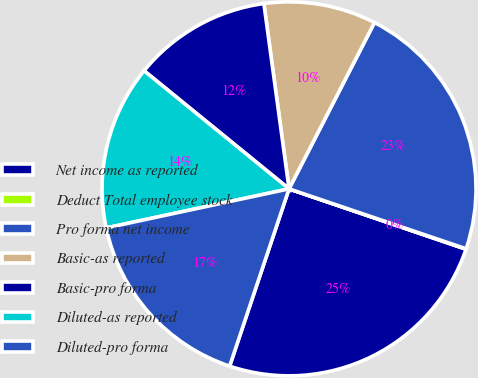Convert chart. <chart><loc_0><loc_0><loc_500><loc_500><pie_chart><fcel>Net income as reported<fcel>Deduct Total employee stock<fcel>Pro forma net income<fcel>Basic-as reported<fcel>Basic-pro forma<fcel>Diluted-as reported<fcel>Diluted-pro forma<nl><fcel>24.91%<fcel>0.04%<fcel>22.64%<fcel>9.7%<fcel>11.97%<fcel>14.23%<fcel>16.5%<nl></chart> 